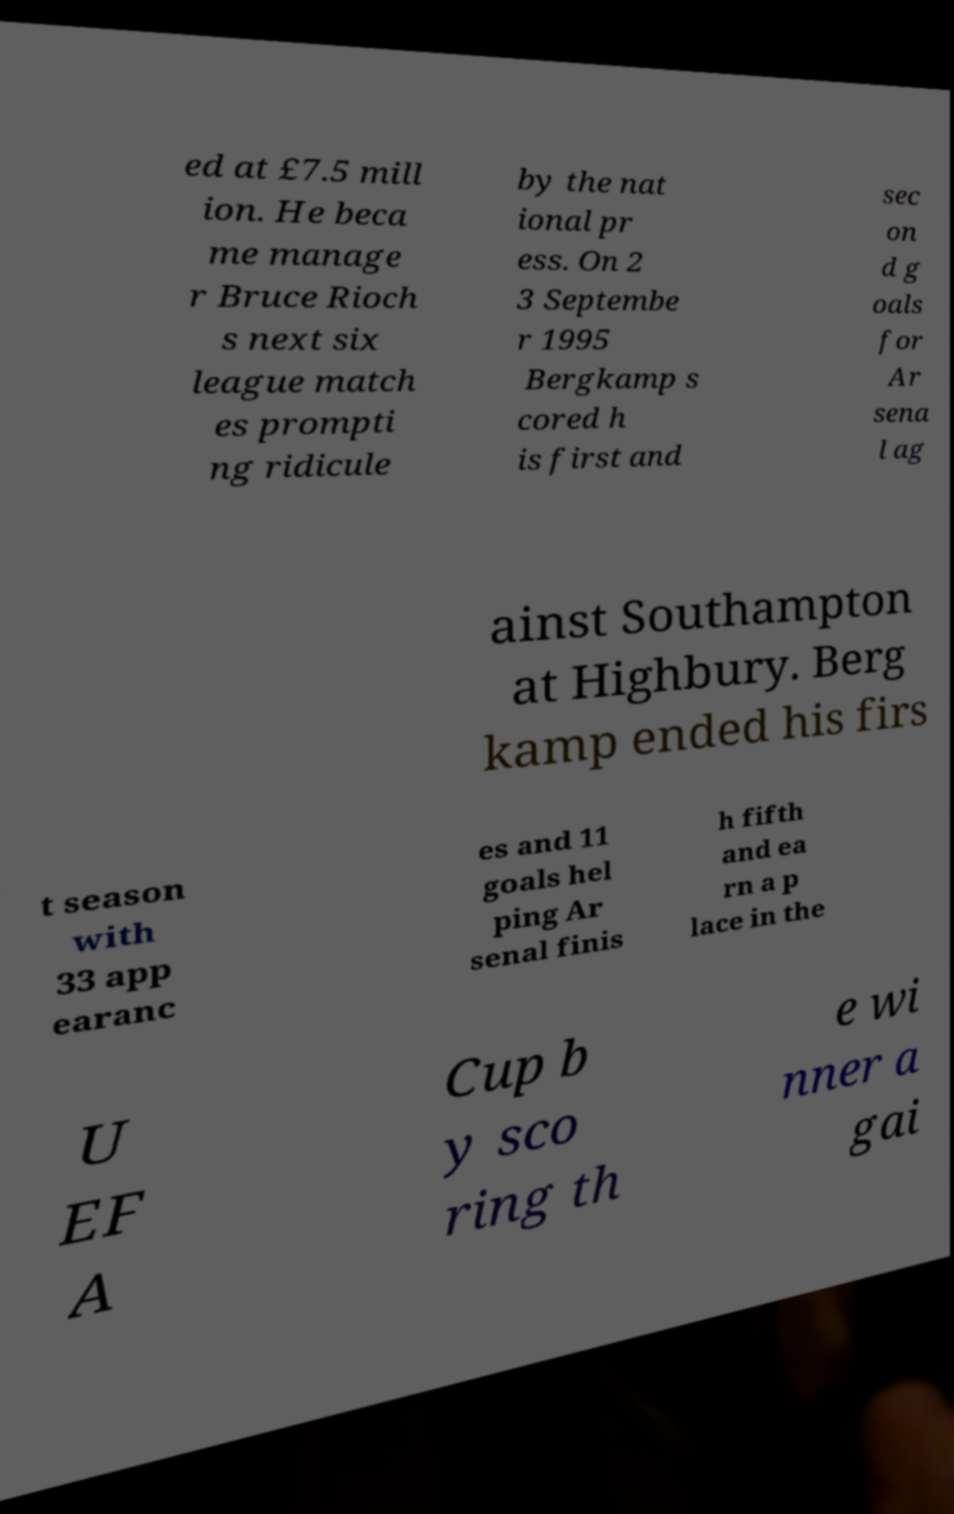For documentation purposes, I need the text within this image transcribed. Could you provide that? ed at £7.5 mill ion. He beca me manage r Bruce Rioch s next six league match es prompti ng ridicule by the nat ional pr ess. On 2 3 Septembe r 1995 Bergkamp s cored h is first and sec on d g oals for Ar sena l ag ainst Southampton at Highbury. Berg kamp ended his firs t season with 33 app earanc es and 11 goals hel ping Ar senal finis h fifth and ea rn a p lace in the U EF A Cup b y sco ring th e wi nner a gai 